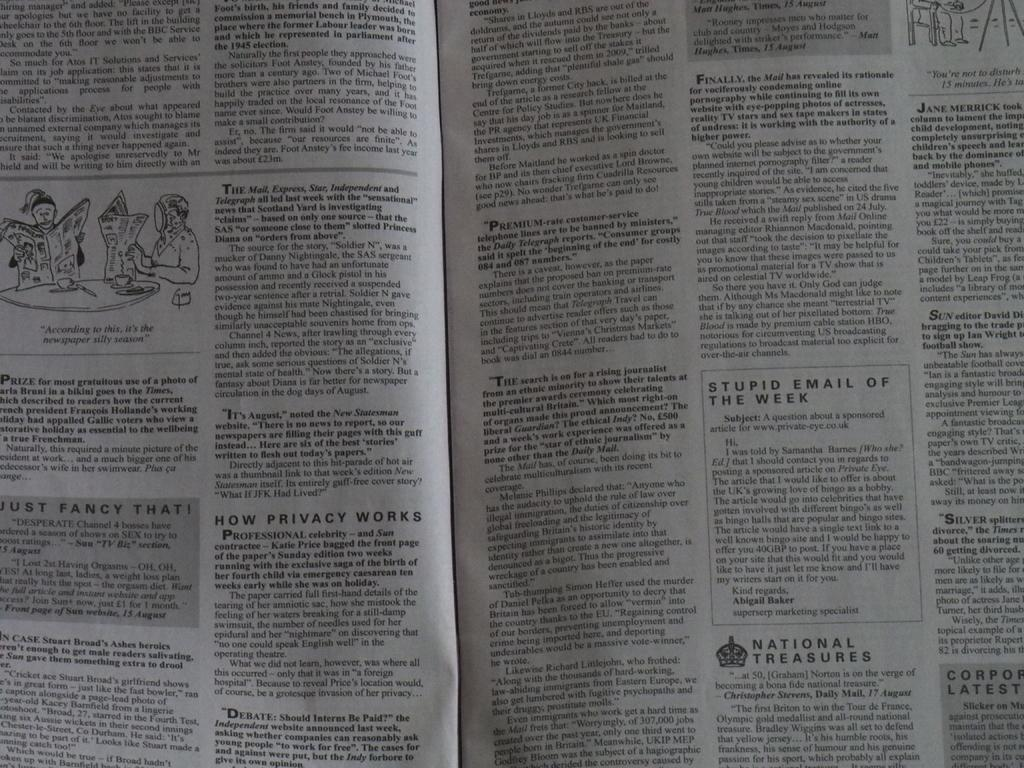Provide a one-sentence caption for the provided image. A newspaper is open to a section called How Privacy Works. 